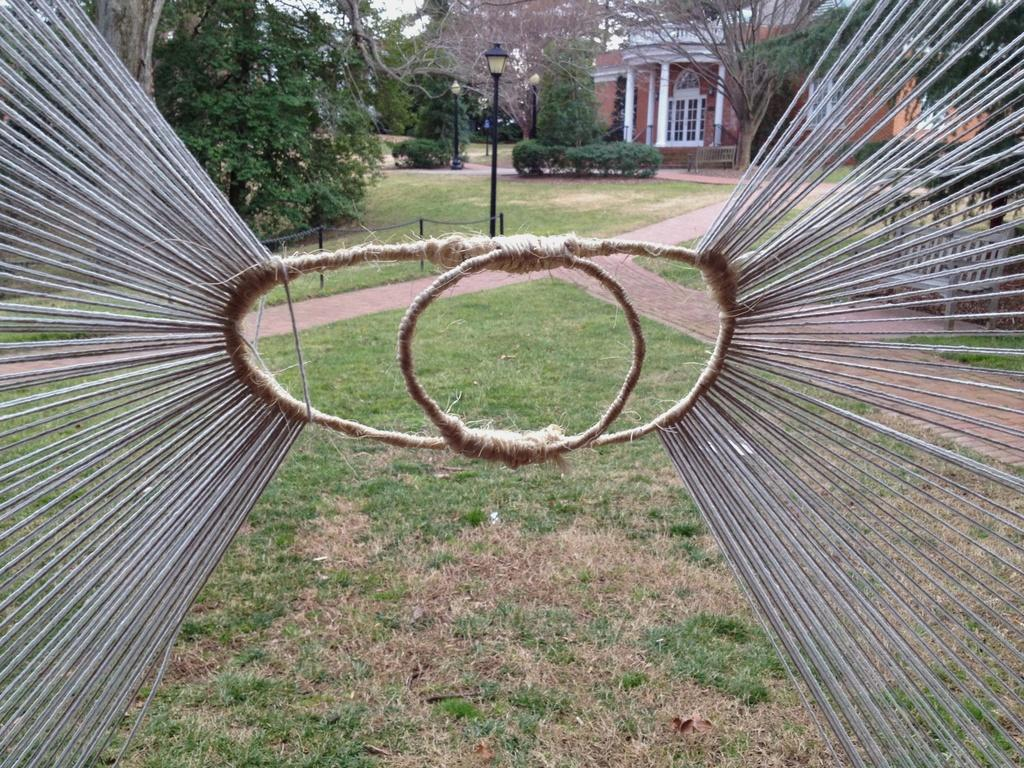What type of vegetation is present on the ground in the front of the image? There is grass on the ground in the front of the image. What object can be seen in the front of the image, along with the grass? There is a rope in the front of the image. What structures are visible in the background of the image? There are poles, trees, and a house in the background of the image. What historical event is being commemorated by the presence of the floor in the image? There is no floor present in the image, and therefore no historical event can be associated with it. What type of stem can be seen growing from the grass in the image? There are no stems growing from the grass in the image; it is simply grass on the ground. 